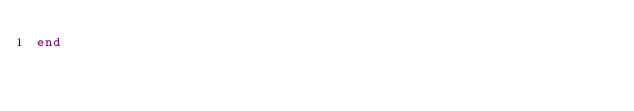Convert code to text. <code><loc_0><loc_0><loc_500><loc_500><_Ruby_>end
</code> 